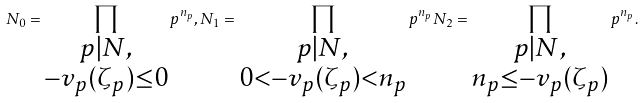<formula> <loc_0><loc_0><loc_500><loc_500>N _ { 0 } = \prod _ { \substack { p | N , \\ - v _ { p } ( \zeta _ { p } ) \leq 0 } } p ^ { n _ { p } } , N _ { 1 } = \prod _ { \substack { p | N , \\ 0 < - v _ { p } ( \zeta _ { p } ) < n _ { p } } } p ^ { n _ { p } } N _ { 2 } = \prod _ { \substack { p | N , \\ n _ { p } \leq - v _ { p } ( \zeta _ { p } ) } } p ^ { n _ { p } } .</formula> 